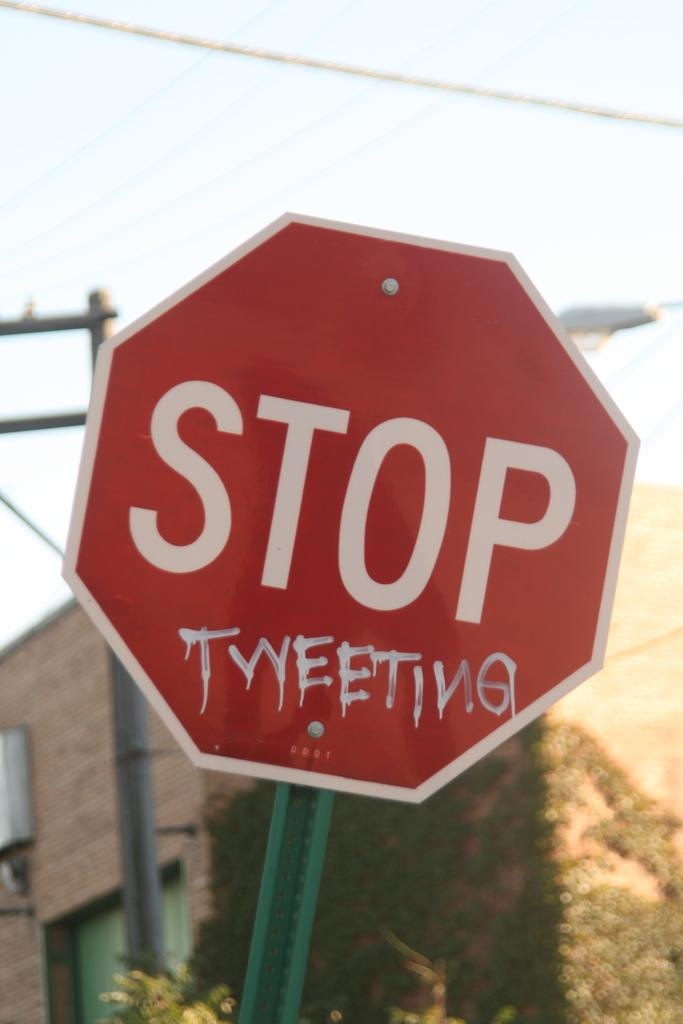<image>
Share a concise interpretation of the image provided. A stop sign that has been vandalised so it now says "STOP TWEETING" 